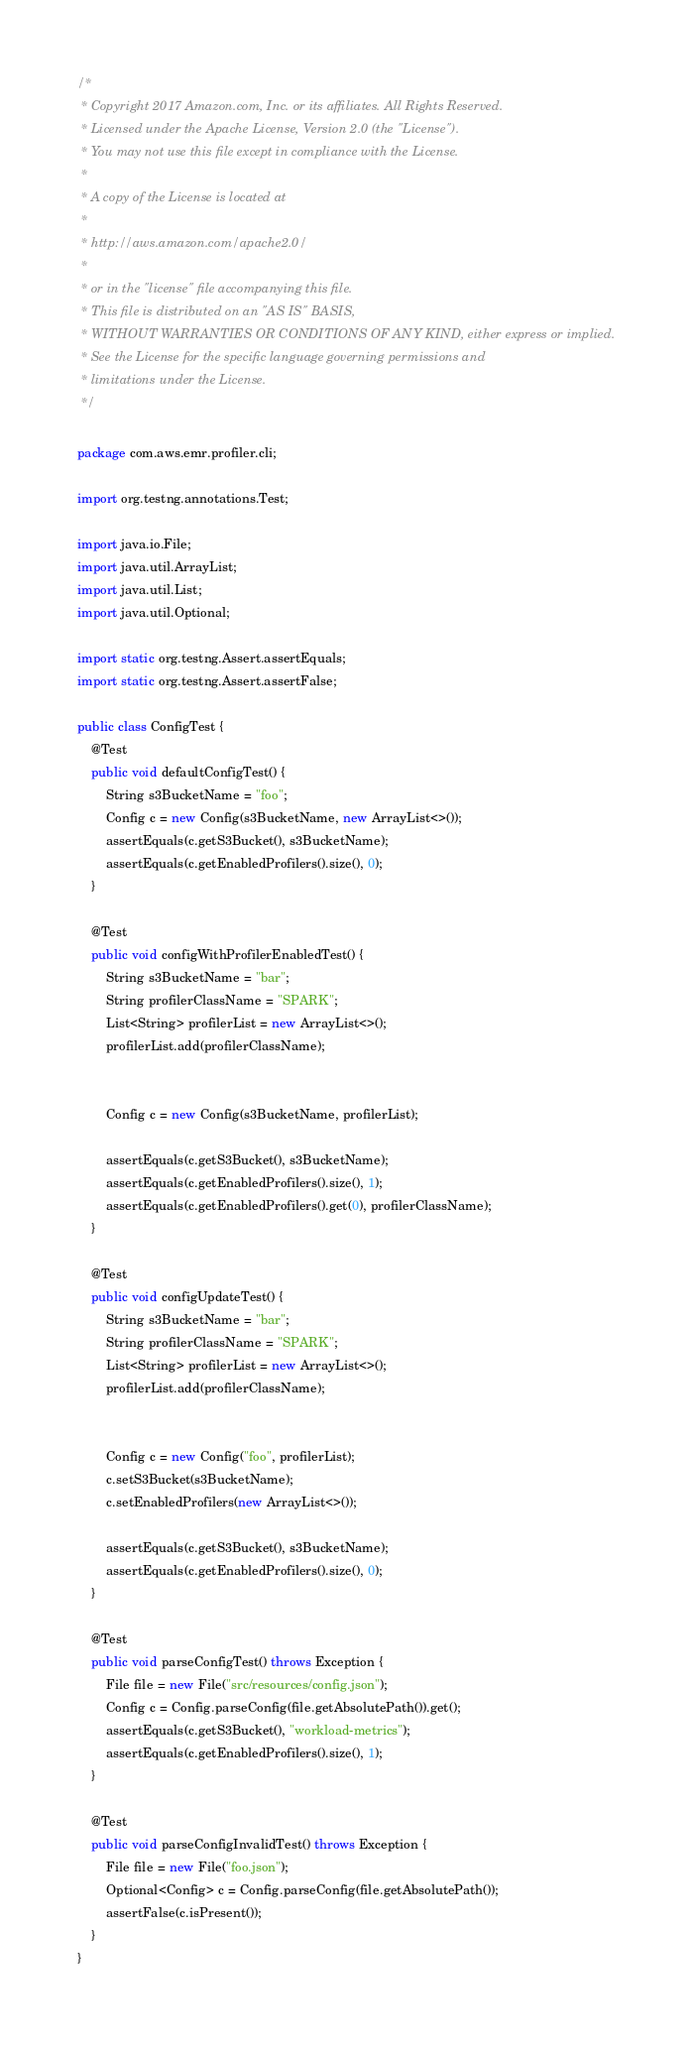Convert code to text. <code><loc_0><loc_0><loc_500><loc_500><_Java_>/*
 * Copyright 2017 Amazon.com, Inc. or its affiliates. All Rights Reserved.
 * Licensed under the Apache License, Version 2.0 (the "License").
 * You may not use this file except in compliance with the License.
 *
 * A copy of the License is located at
 *
 * http://aws.amazon.com/apache2.0/
 *
 * or in the "license" file accompanying this file.
 * This file is distributed on an "AS IS" BASIS,
 * WITHOUT WARRANTIES OR CONDITIONS OF ANY KIND, either express or implied.
 * See the License for the specific language governing permissions and
 * limitations under the License.
 */

package com.aws.emr.profiler.cli;

import org.testng.annotations.Test;

import java.io.File;
import java.util.ArrayList;
import java.util.List;
import java.util.Optional;

import static org.testng.Assert.assertEquals;
import static org.testng.Assert.assertFalse;

public class ConfigTest {
    @Test
    public void defaultConfigTest() {
        String s3BucketName = "foo";
        Config c = new Config(s3BucketName, new ArrayList<>());
        assertEquals(c.getS3Bucket(), s3BucketName);
        assertEquals(c.getEnabledProfilers().size(), 0);
    }

    @Test
    public void configWithProfilerEnabledTest() {
        String s3BucketName = "bar";
        String profilerClassName = "SPARK";
        List<String> profilerList = new ArrayList<>();
        profilerList.add(profilerClassName);


        Config c = new Config(s3BucketName, profilerList);

        assertEquals(c.getS3Bucket(), s3BucketName);
        assertEquals(c.getEnabledProfilers().size(), 1);
        assertEquals(c.getEnabledProfilers().get(0), profilerClassName);
    }

    @Test
    public void configUpdateTest() {
        String s3BucketName = "bar";
        String profilerClassName = "SPARK";
        List<String> profilerList = new ArrayList<>();
        profilerList.add(profilerClassName);


        Config c = new Config("foo", profilerList);
        c.setS3Bucket(s3BucketName);
        c.setEnabledProfilers(new ArrayList<>());

        assertEquals(c.getS3Bucket(), s3BucketName);
        assertEquals(c.getEnabledProfilers().size(), 0);
    }

    @Test
    public void parseConfigTest() throws Exception {
        File file = new File("src/resources/config.json");
        Config c = Config.parseConfig(file.getAbsolutePath()).get();
        assertEquals(c.getS3Bucket(), "workload-metrics");
        assertEquals(c.getEnabledProfilers().size(), 1);
    }

    @Test
    public void parseConfigInvalidTest() throws Exception {
        File file = new File("foo.json");
        Optional<Config> c = Config.parseConfig(file.getAbsolutePath());
        assertFalse(c.isPresent());
    }
}
</code> 